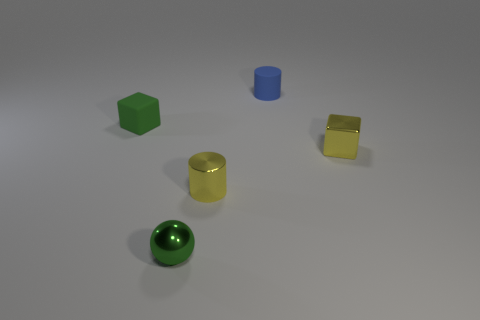There is a metal object that is the same color as the small metal cube; what is its shape?
Your response must be concise. Cylinder. What color is the small cylinder in front of the green matte cube?
Give a very brief answer. Yellow. How many things are either blocks that are on the right side of the green matte object or gray things?
Provide a succinct answer. 1. There is a rubber cylinder that is the same size as the shiny cylinder; what is its color?
Offer a terse response. Blue. Is the number of yellow objects that are on the left side of the matte cube greater than the number of green balls?
Offer a terse response. No. What is the material of the object that is both left of the rubber cylinder and right of the small green metallic sphere?
Provide a short and direct response. Metal. Is the color of the small cube to the right of the tiny blue rubber cylinder the same as the rubber thing that is in front of the tiny blue matte thing?
Your answer should be very brief. No. How many other things are the same size as the yellow block?
Keep it short and to the point. 4. There is a small green thing that is to the right of the small green thing behind the small metal sphere; is there a small cylinder on the right side of it?
Ensure brevity in your answer.  Yes. Is the material of the small cube left of the tiny blue rubber object the same as the blue cylinder?
Offer a terse response. Yes. 